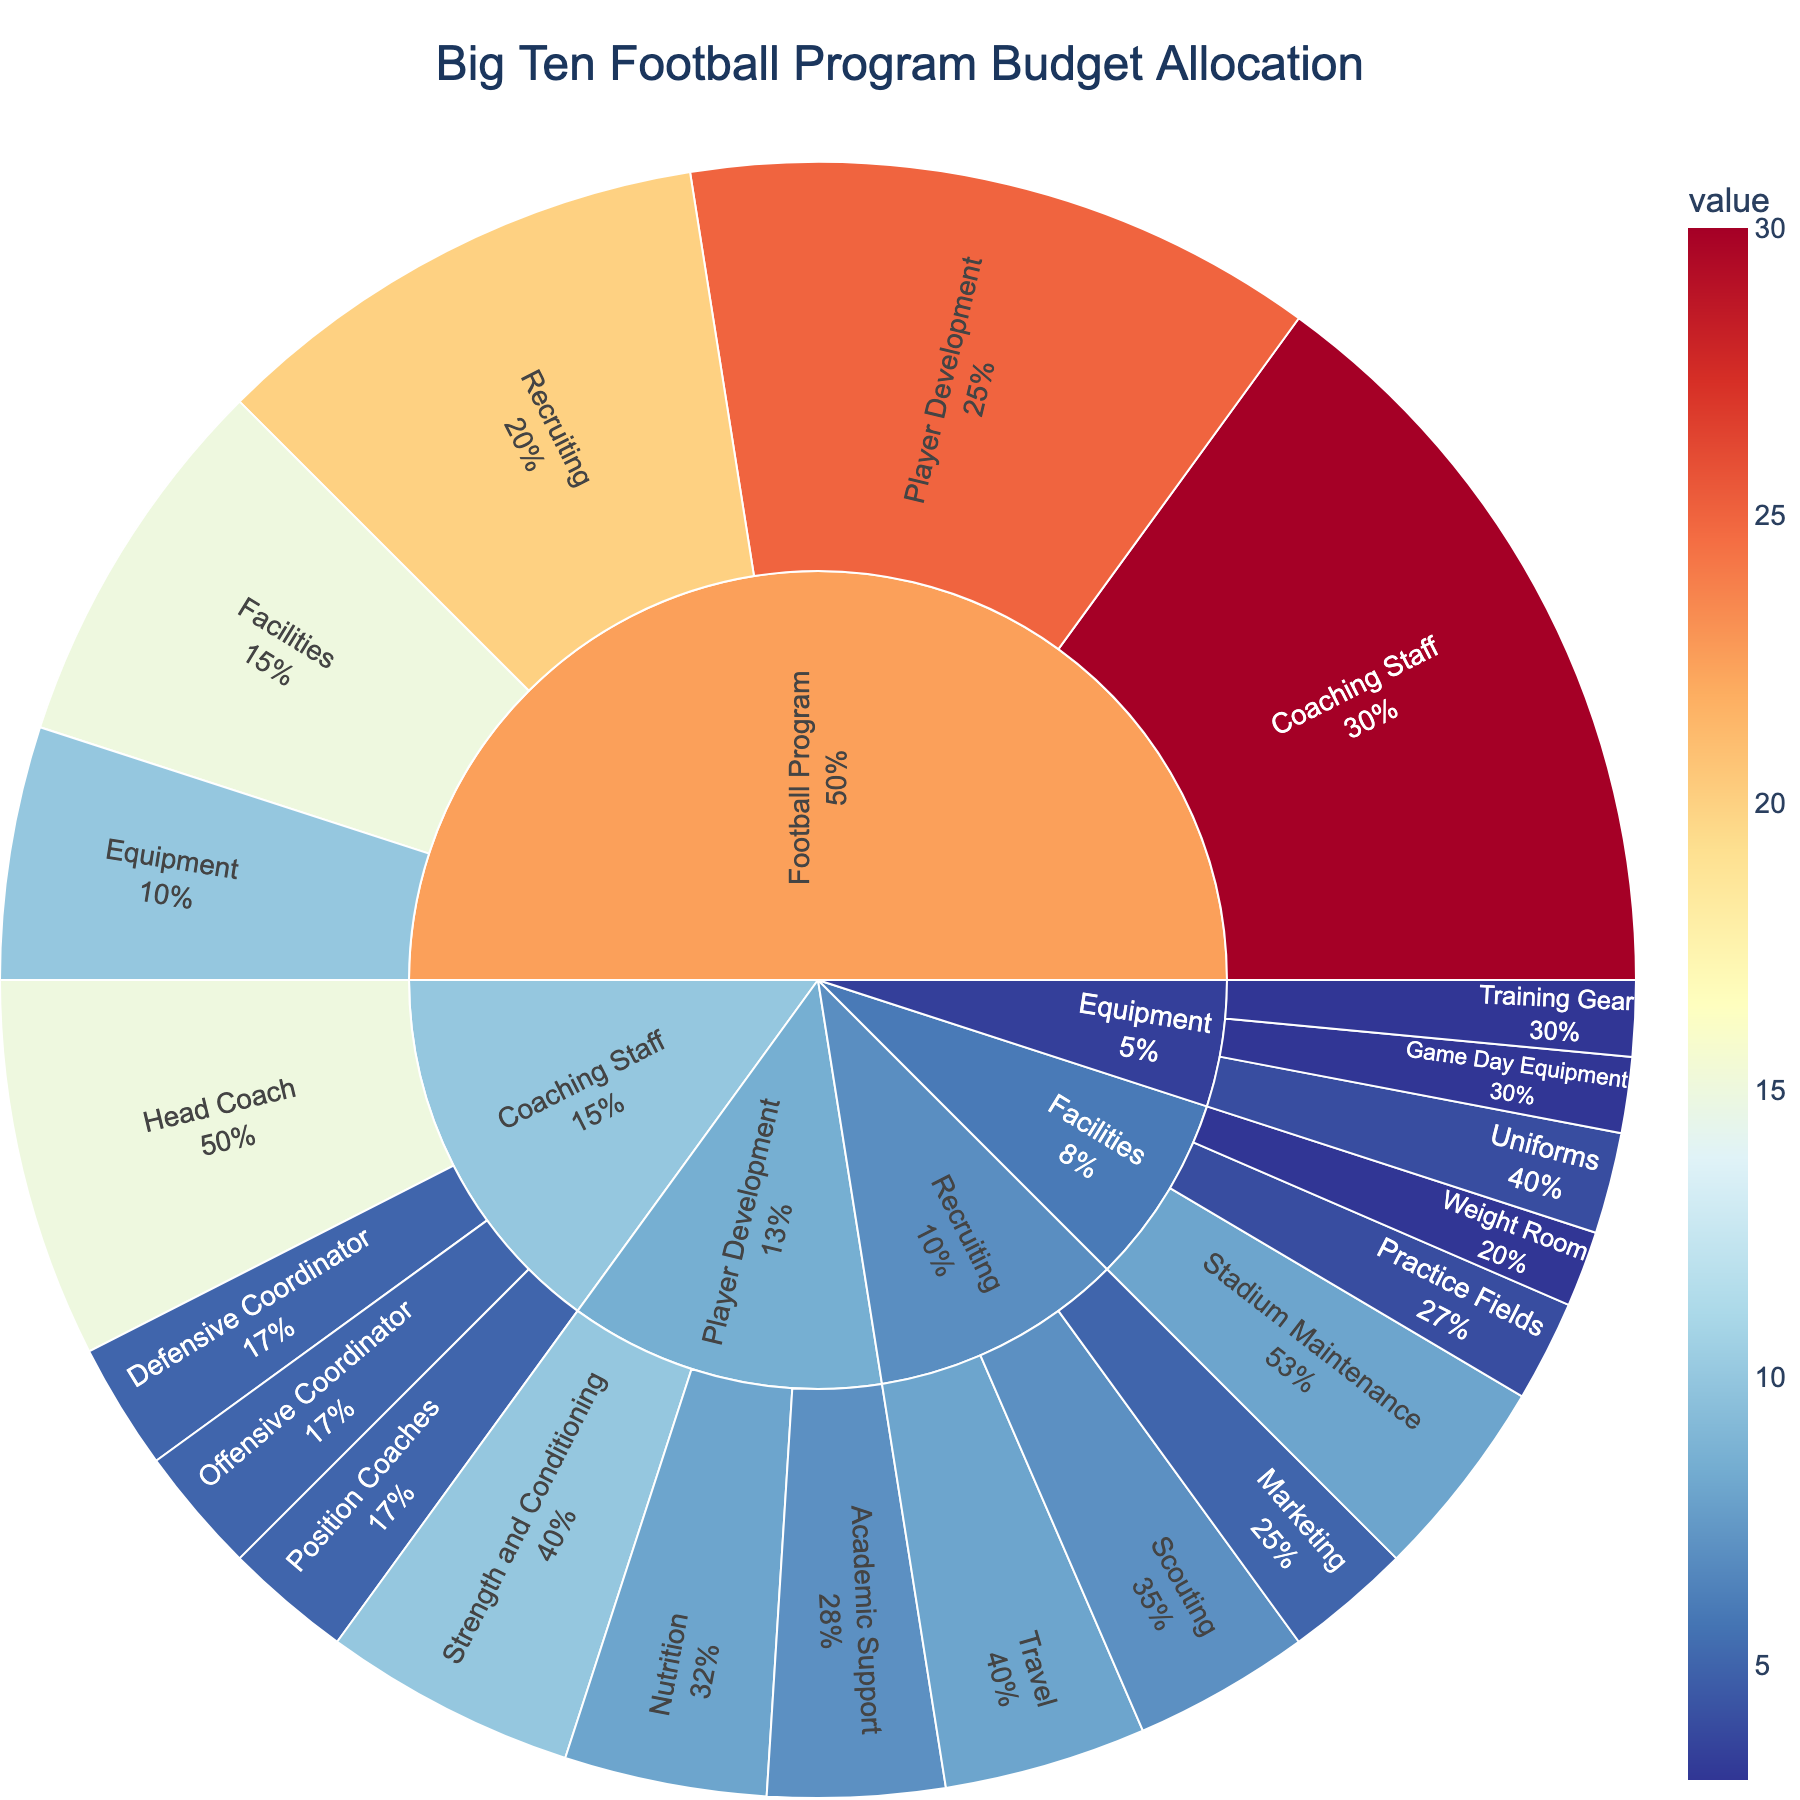What's the largest budget category in the football program? The largest budget category can be directly observed in the Sunburst Plot as the one with the largest segment. This segment will extend the farthest from the center of the plot. By examining the plot, we see that the "Coaching Staff" category extends the farthest.
Answer: Coaching Staff What percentage of the budget is allocated to 'Recruiting'? To find the percentage allocated to 'Recruiting', one can refer to the corresponding segment in the Sunburst Plot and check the hover information or the labeled percentage within the segment. In this case, the 'Recruiting' segment indicates 20% of the budget.
Answer: 20% Of the Player Development budget, which subcategory receives the largest share? Focusing on the 'Player Development' segment of the plot and looking at its subsidiary segments, we compare their sizes. The 'Strength and Conditioning' segment is the largest, indicating it receives the most substantial share.
Answer: Strength and Conditioning How much of the total 'Coaching Staff' budget is allocated to the Head Coach? Examine the 'Coaching Staff' segment, then look at the proportion allocated to its subcategories. The 'Head Coach' portion of the 'Coaching Staff' segment is clearly labeled with both the value and its percentage of the 'Coaching Staff' budget. This will be 15 out of 30.
Answer: 15 Which category is allocated a smaller budget, Player Development or Equipment? To compare, look at the sizes of the segments for 'Player Development' and 'Equipment'. It's clear that 'Player Development' is larger. Hence, 'Equipment' has a smaller budget.
Answer: Equipment What is the combined budget for 'Stadium Maintenance' and 'Practice Fields'? Identify the subsegments under 'Facilities' corresponding to 'Stadium Maintenance' and 'Practice Fields'. Sum their values: 8 (Stadium Maintenance) + 4 (Practice Fields).
Answer: 12 Which subcategory under 'Recruiting' has the smallest budget? Under the 'Recruiting' segment on the Sunburst Plot, the smallest subsegment will correspond to the smallest budget. Here, 'Marketing' shows the smallest segment.
Answer: Marketing What percentage of the 'Equipment' budget is allocated to 'Uniforms'? In the 'Equipment' segment, examine the corresponding subsegments. The percentage for 'Uniforms' is displayed by hovering over or within the segment label, which is 4 out of 10.
Answer: 40% What is the total budget allocated to 'Facilities'? Sum the subcategory values under 'Facilities'. Adding 'Stadium Maintenance' (8), 'Practice Fields' (4), and 'Weight Room' (3), the total budget is 15.
Answer: 15 How does the budget for 'Defensive Coordinator' compare to the budget for 'Scouting'? Compare the sizes of the 'Defensive Coordinator' segment under 'Coaching Staff' and the 'Scouting' segment under 'Recruiting'. Both segments are equal in size, each allocated 5 units.
Answer: Equal 